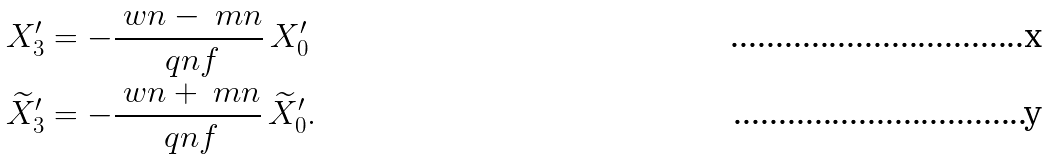Convert formula to latex. <formula><loc_0><loc_0><loc_500><loc_500>X _ { 3 } ^ { \prime } & = - \frac { \ w n - \ m n } { \ q n f } \, X _ { 0 } ^ { \prime } \\ \widetilde { X } _ { 3 } ^ { \prime } & = - \frac { \ w n + \ m n } { \ q n f } \, \widetilde { X } _ { 0 } ^ { \prime } .</formula> 